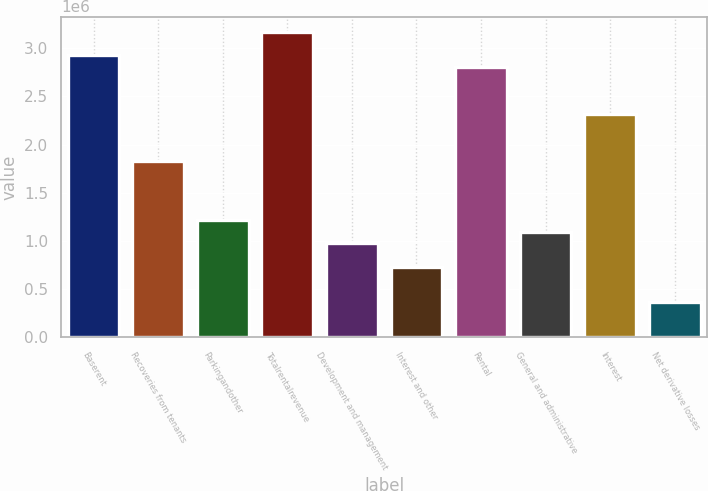Convert chart. <chart><loc_0><loc_0><loc_500><loc_500><bar_chart><fcel>Baserent<fcel>Recoveries from tenants<fcel>Parkingandother<fcel>Totalrentalrevenue<fcel>Development and management<fcel>Interest and other<fcel>Rental<fcel>General and administrative<fcel>Interest<fcel>Net derivative losses<nl><fcel>2.92599e+06<fcel>1.82875e+06<fcel>1.21916e+06<fcel>3.16983e+06<fcel>975332<fcel>731499<fcel>2.80408e+06<fcel>1.09725e+06<fcel>2.31641e+06<fcel>365750<nl></chart> 